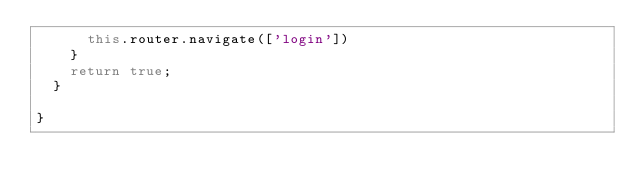<code> <loc_0><loc_0><loc_500><loc_500><_TypeScript_>      this.router.navigate(['login'])
    }
    return true;
  }

}</code> 